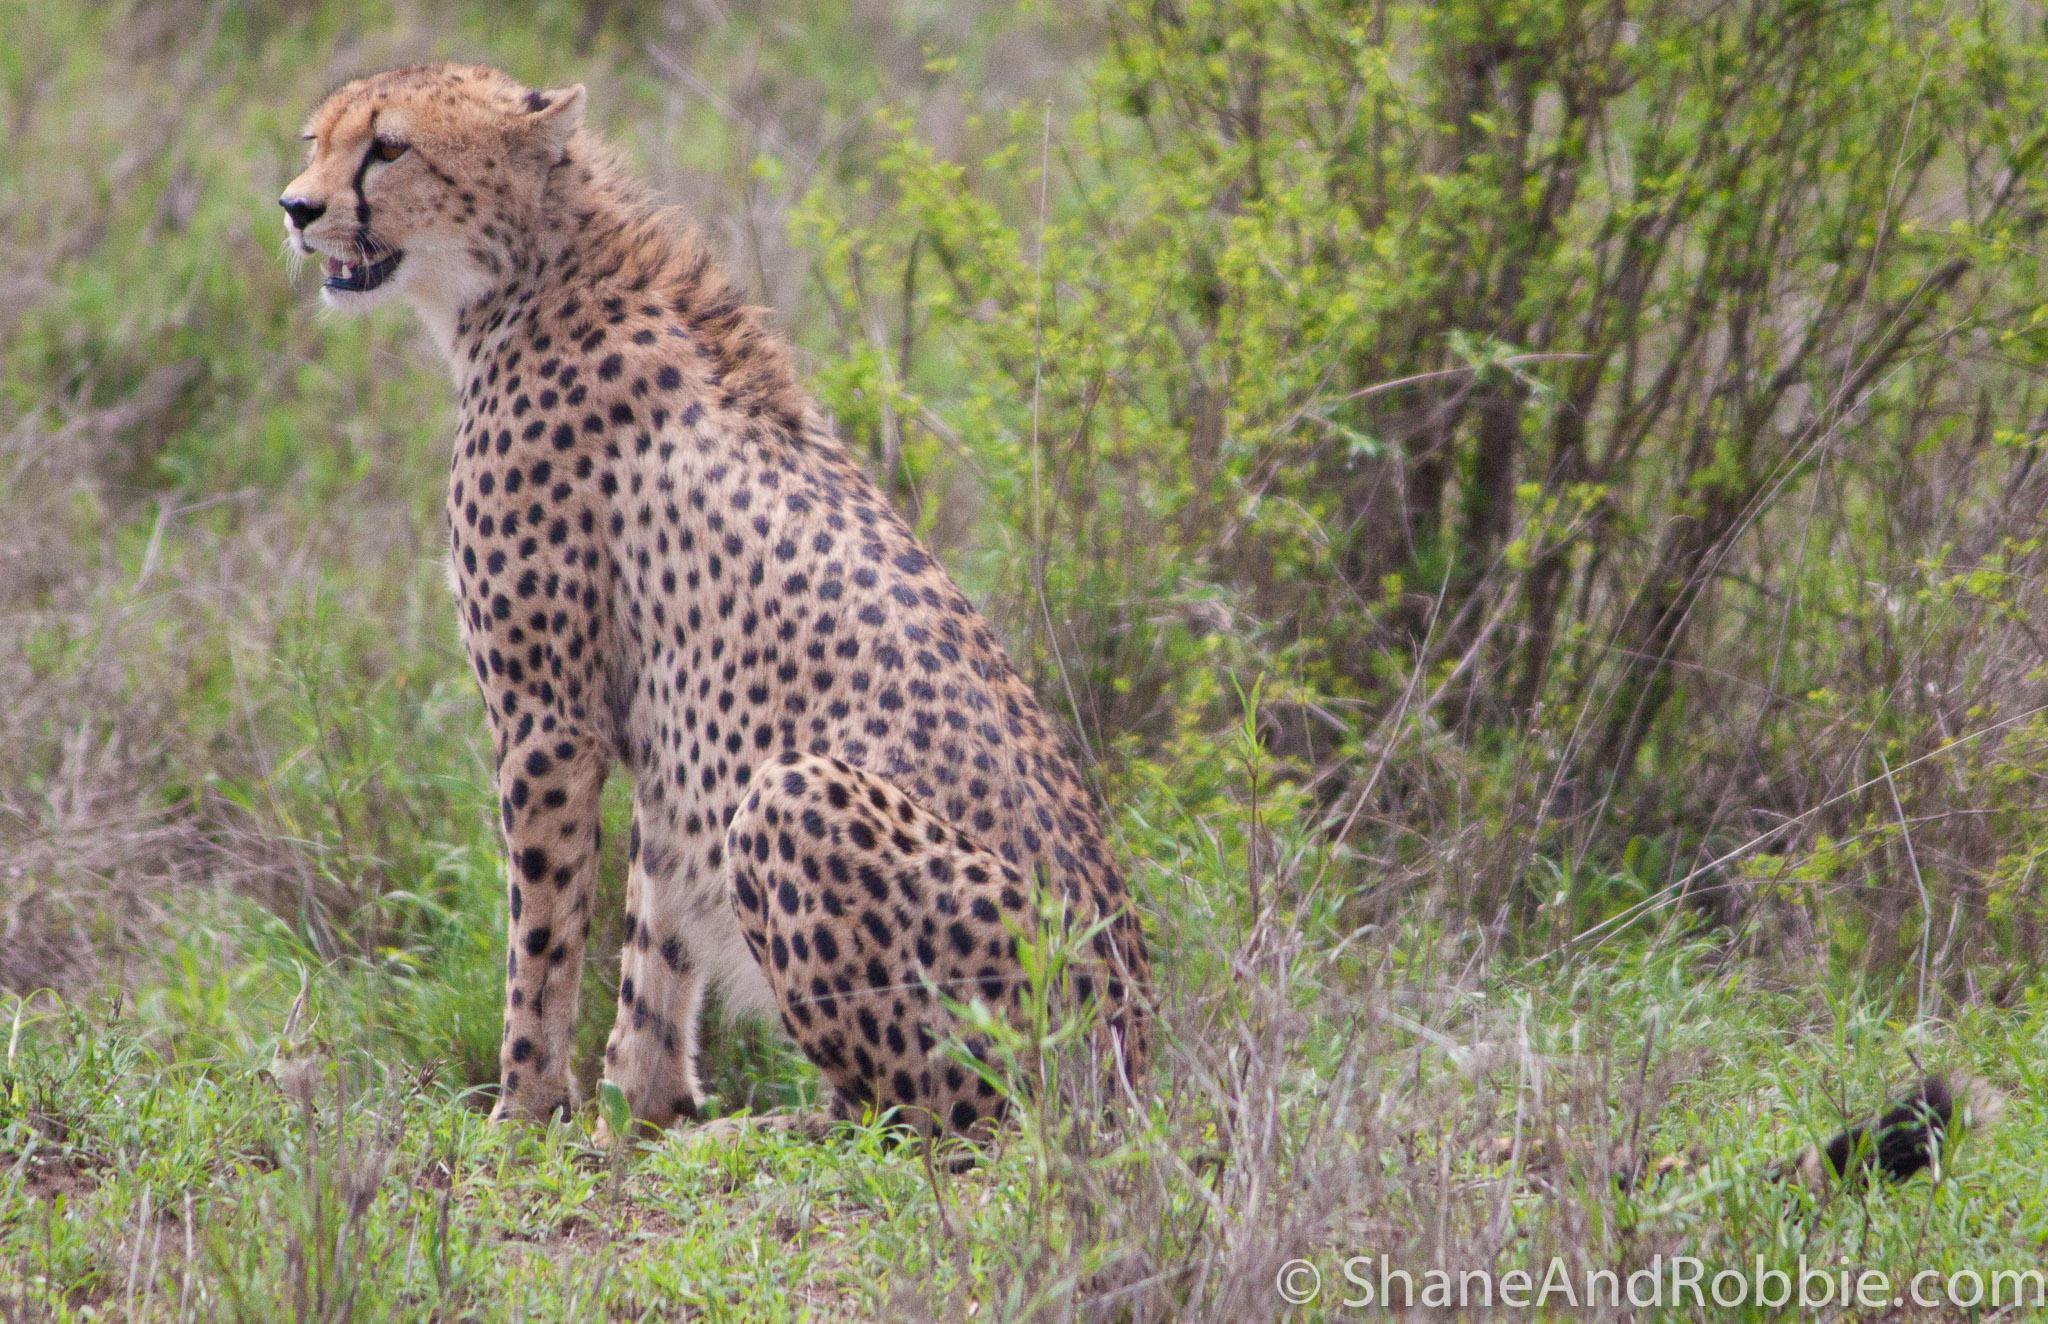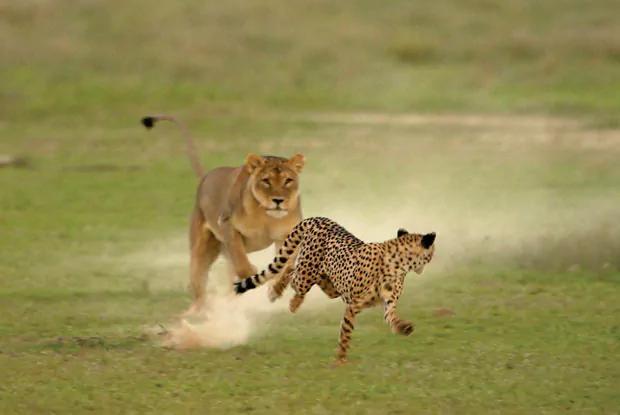The first image is the image on the left, the second image is the image on the right. Considering the images on both sides, is "One image features one cheetah bounding forward." valid? Answer yes or no. No. 